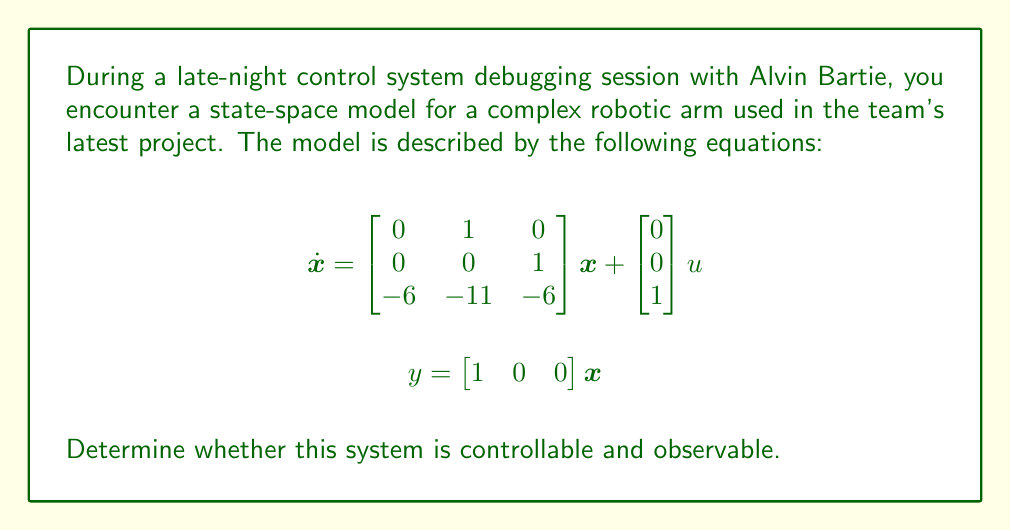Show me your answer to this math problem. To determine the controllability and observability of the system, we need to check the ranks of the controllability and observability matrices.

1. Controllability:
The controllability matrix is given by $C = [B \quad AB \quad A^2B]$, where $A$ is the system matrix and $B$ is the input matrix.

$B = \begin{bmatrix} 0 \\ 0 \\ 1 \end{bmatrix}$

$AB = \begin{bmatrix} 0 & 1 & 0 \\ 0 & 0 & 1 \\ -6 & -11 & -6 \end{bmatrix} \begin{bmatrix} 0 \\ 0 \\ 1 \end{bmatrix} = \begin{bmatrix} 0 \\ 1 \\ -6 \end{bmatrix}$

$A^2B = \begin{bmatrix} 0 & 1 & 0 \\ 0 & 0 & 1 \\ -6 & -11 & -6 \end{bmatrix} \begin{bmatrix} 0 \\ 1 \\ -6 \end{bmatrix} = \begin{bmatrix} 1 \\ -6 \\ -5 \end{bmatrix}$

Therefore, the controllability matrix is:

$C = \begin{bmatrix} 0 & 0 & 1 \\ 0 & 1 & -6 \\ 1 & -6 & -5 \end{bmatrix}$

The rank of $C$ is 3, which is equal to the number of states. Thus, the system is controllable.

2. Observability:
The observability matrix is given by $O = [C^T \quad A^TC^T \quad (A^T)^2C^T]$, where $C$ is the output matrix.

$C^T = \begin{bmatrix} 1 \\ 0 \\ 0 \end{bmatrix}$

$A^TC^T = \begin{bmatrix} 0 & 0 & -6 \\ 1 & 0 & -11 \\ 0 & 1 & -6 \end{bmatrix} \begin{bmatrix} 1 \\ 0 \\ 0 \end{bmatrix} = \begin{bmatrix} 0 \\ 1 \\ 0 \end{bmatrix}$

$(A^T)^2C^T = \begin{bmatrix} 0 & 0 & -6 \\ 1 & 0 & -11 \\ 0 & 1 & -6 \end{bmatrix} \begin{bmatrix} 0 \\ 1 \\ 0 \end{bmatrix} = \begin{bmatrix} 0 \\ 0 \\ 1 \end{bmatrix}$

Therefore, the observability matrix is:

$O = \begin{bmatrix} 1 & 0 & 0 \\ 0 & 1 & 0 \\ 0 & 0 & 1 \end{bmatrix}$

The rank of $O$ is 3, which is equal to the number of states. Thus, the system is observable.
Answer: The system is both controllable and observable. 